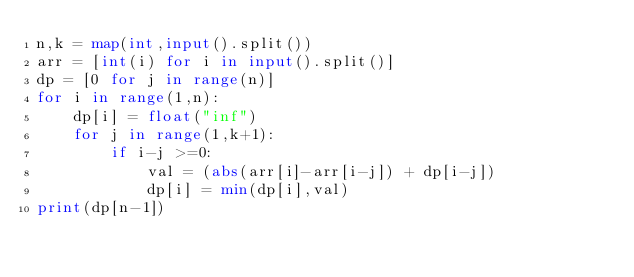<code> <loc_0><loc_0><loc_500><loc_500><_Python_>n,k = map(int,input().split())
arr = [int(i) for i in input().split()]
dp = [0 for j in range(n)]
for i in range(1,n):
    dp[i] = float("inf")
    for j in range(1,k+1):
        if i-j >=0:
            val = (abs(arr[i]-arr[i-j]) + dp[i-j]) 
            dp[i] = min(dp[i],val)
print(dp[n-1])
</code> 